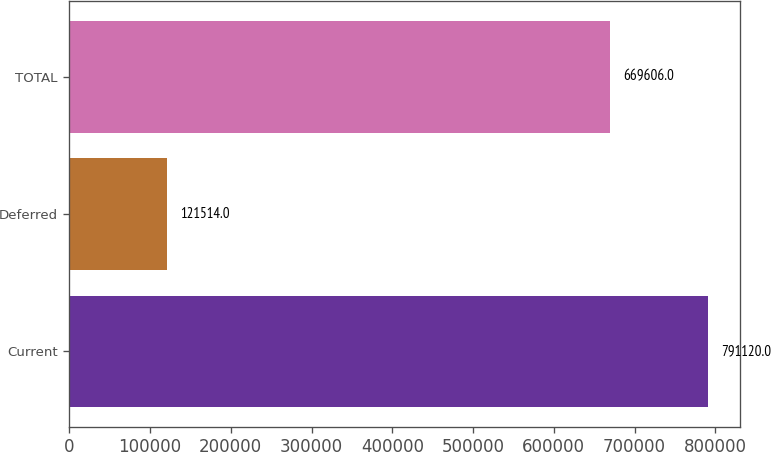<chart> <loc_0><loc_0><loc_500><loc_500><bar_chart><fcel>Current<fcel>Deferred<fcel>TOTAL<nl><fcel>791120<fcel>121514<fcel>669606<nl></chart> 